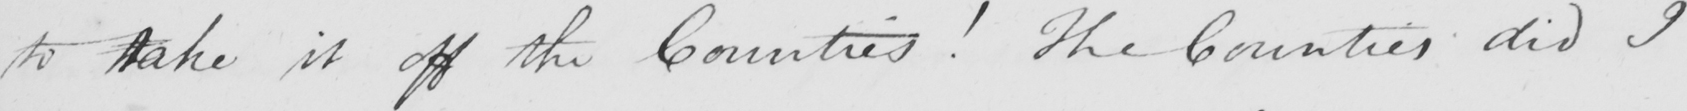Transcribe the text shown in this historical manuscript line. to take it off the Counties !  The Counties did I 